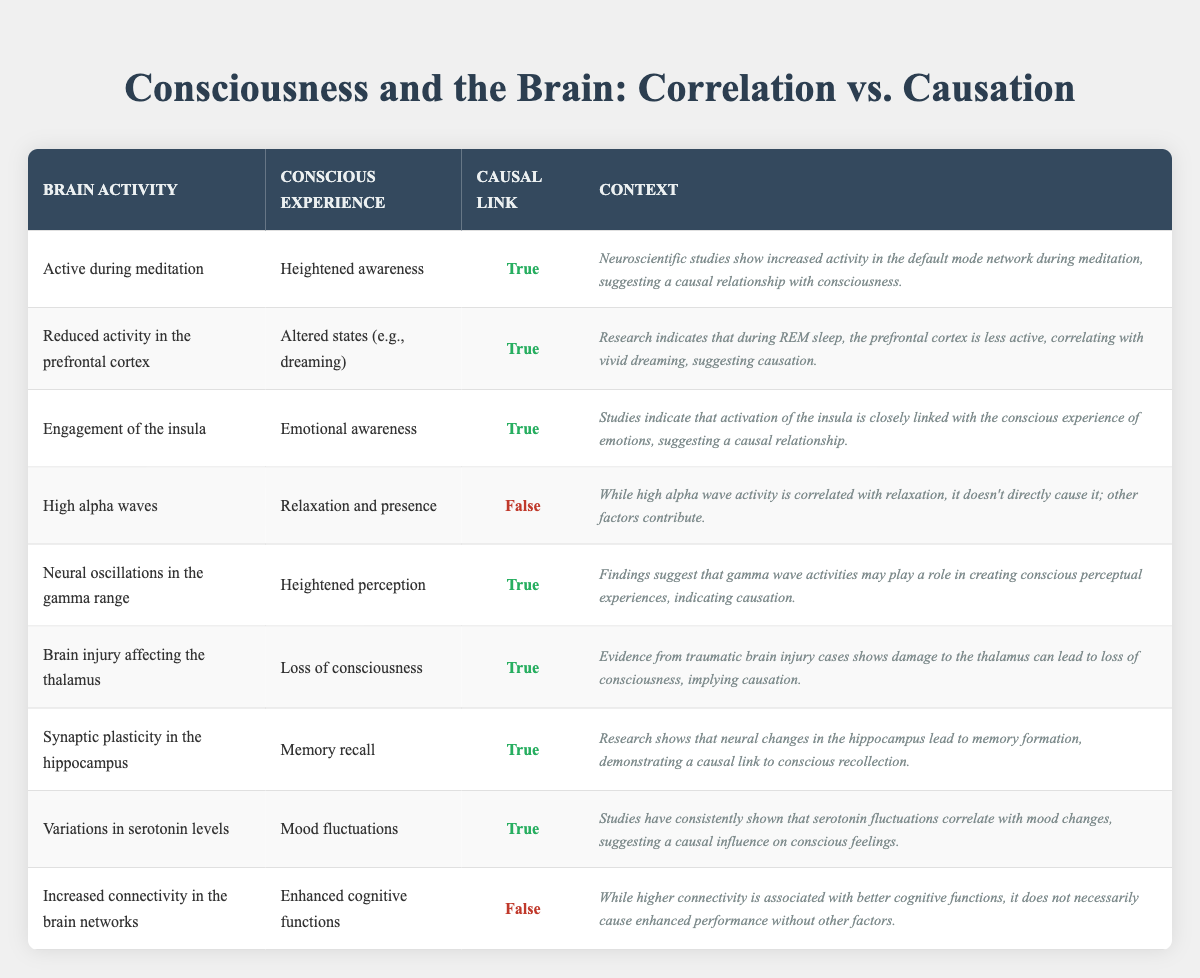What is the brain activity associated with heightened awareness? The table states that "Active during meditation" is the brain activity associated with heightened awareness.
Answer: Active during meditation Which conscious experience is linked to reduced activity in the prefrontal cortex? The table indicates that "Altered states (e.g., dreaming)" is the conscious experience linked to reduced activity in the prefrontal cortex.
Answer: Altered states (e.g., dreaming) How many entries in the table suggest a true causal link between brain activity and consciousness? There are 6 entries in the table that indicate a true causal link (indicated by "True" in the causal link column).
Answer: 6 Is there a causal link between high alpha waves and relaxation? According to the table, the causal link for high alpha waves is marked as "False," indicating that there is no direct causal link.
Answer: No What are the conscious experiences associated with brain activity that shows a causal link? The conscious experiences associated with a causal link are: heightened awareness, altered states (e.g., dreaming), emotional awareness, heightened perception, loss of consciousness, memory recall, and mood fluctuations.
Answer: Heightened awareness, altered states (e.g., dreaming), emotional awareness, heightened perception, loss of consciousness, memory recall, mood fluctuations What is the context for the relationship between neural oscillations in the gamma range and heightened perception? The context is that findings suggest gamma wave activities may play a role in creating conscious perceptual experiences, indicating causation.
Answer: Gamma wave activities create perceptual experiences Describe the relationship between synaptic plasticity in the hippocampus and memory recall. The relationship is that research shows neural changes in the hippocampus lead to memory formation, demonstrating a causal link to conscious recollection.
Answer: Causal link to memory formation What is the relationship between variations in serotonin levels and mood fluctuations? The table states that studies have consistently shown fluctuations in serotonin correlate with mood changes, suggesting a causal influence on conscious feelings.
Answer: Causal influence on mood changes 